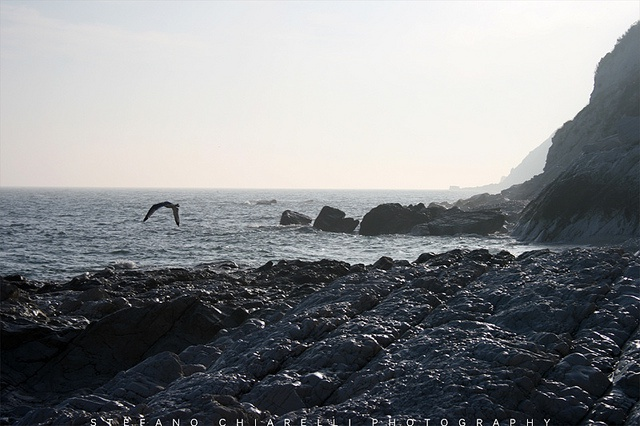Describe the objects in this image and their specific colors. I can see a bird in lightgray, black, darkgray, and gray tones in this image. 